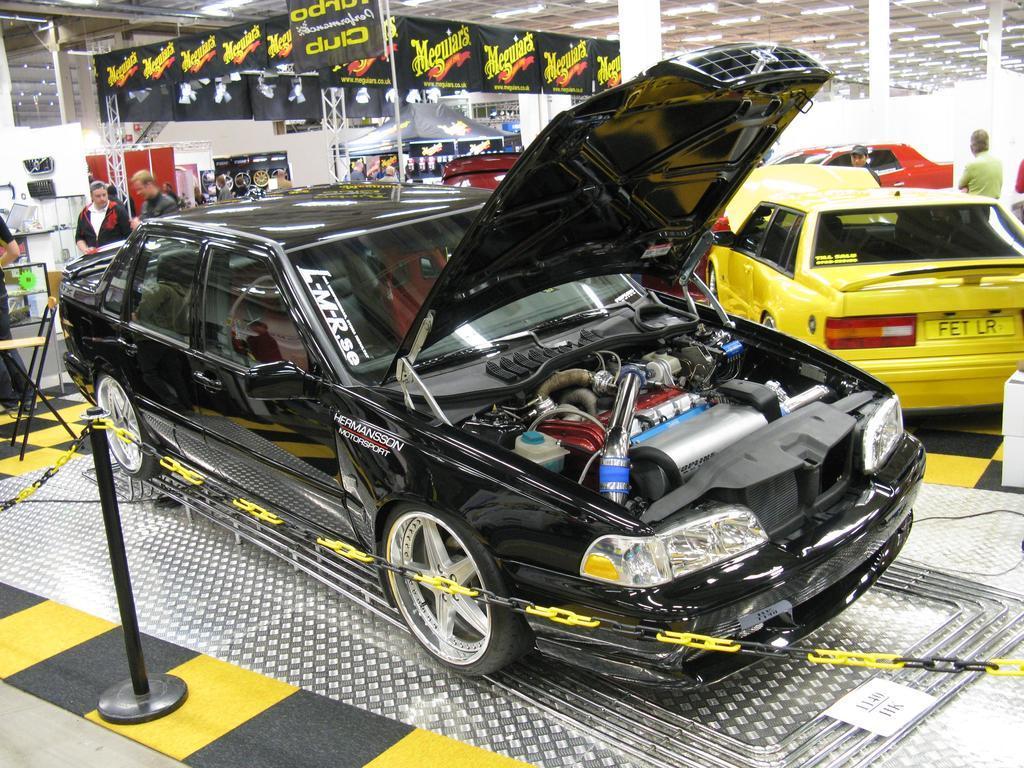How would you summarize this image in a sentence or two? In this image it seems like it is a car repair shop. In the middle there is a black color car which is surrounded by the fence. The hood of the car is opened and we can see the motor and other parts of the car. At the top there is ceiling with the lights. In the background there are few other cars and few people in between them. On the left side there are two persons standing on the floor and talking with each other. In the background there is a tent under which there are so many banners. There is a chair beside the car. There are few parts which are attached to the wall. 